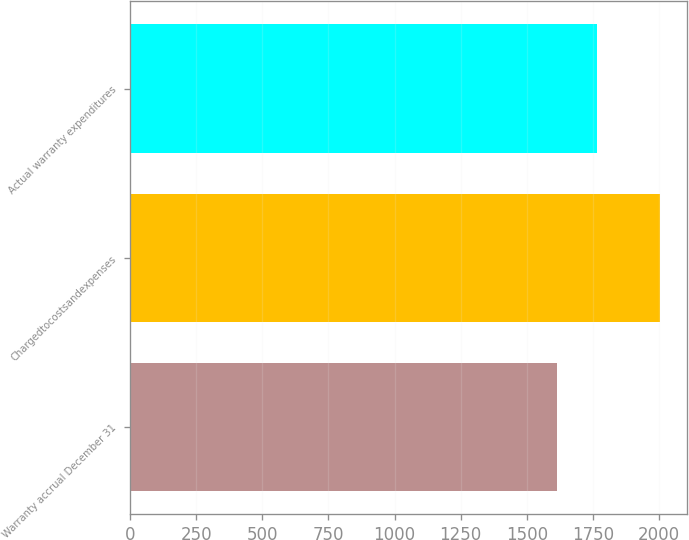<chart> <loc_0><loc_0><loc_500><loc_500><bar_chart><fcel>Warranty accrual December 31<fcel>Chargedtocostsandexpenses<fcel>Actual warranty expenditures<nl><fcel>1616<fcel>2004<fcel>1765<nl></chart> 